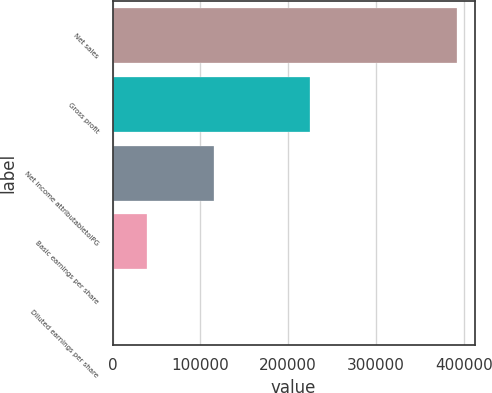Convert chart to OTSL. <chart><loc_0><loc_0><loc_500><loc_500><bar_chart><fcel>Net sales<fcel>Gross profit<fcel>Net income attributabletoIPG<fcel>Basic earnings per share<fcel>Diluted earnings per share<nl><fcel>392615<fcel>224555<fcel>115597<fcel>39263.4<fcel>2.11<nl></chart> 